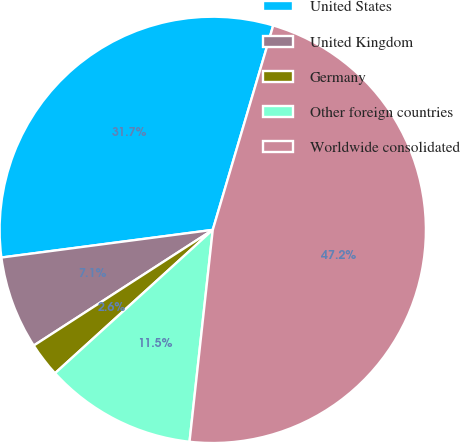Convert chart. <chart><loc_0><loc_0><loc_500><loc_500><pie_chart><fcel>United States<fcel>United Kingdom<fcel>Germany<fcel>Other foreign countries<fcel>Worldwide consolidated<nl><fcel>31.65%<fcel>7.06%<fcel>2.61%<fcel>11.52%<fcel>47.16%<nl></chart> 